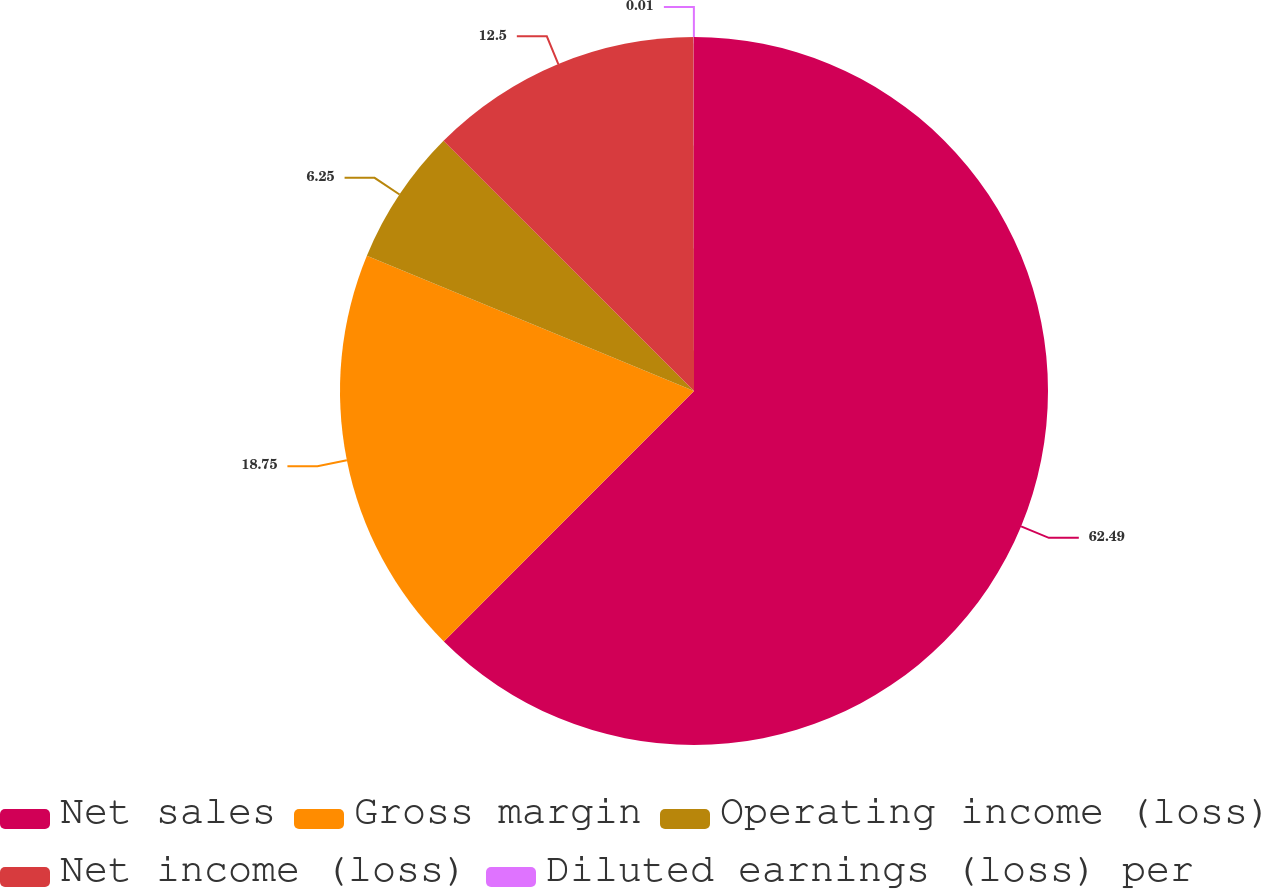Convert chart to OTSL. <chart><loc_0><loc_0><loc_500><loc_500><pie_chart><fcel>Net sales<fcel>Gross margin<fcel>Operating income (loss)<fcel>Net income (loss)<fcel>Diluted earnings (loss) per<nl><fcel>62.49%<fcel>18.75%<fcel>6.25%<fcel>12.5%<fcel>0.01%<nl></chart> 